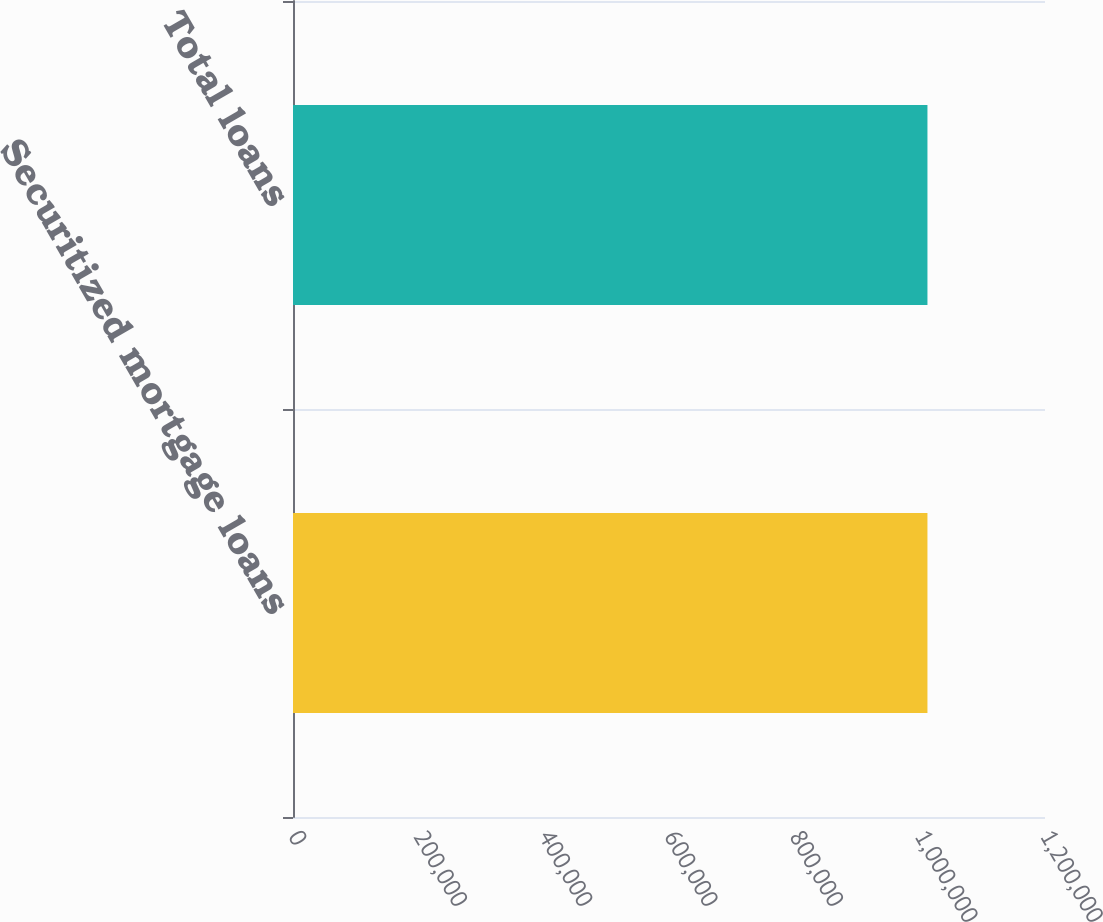Convert chart. <chart><loc_0><loc_0><loc_500><loc_500><bar_chart><fcel>Securitized mortgage loans<fcel>Total loans<nl><fcel>1.01241e+06<fcel>1.01241e+06<nl></chart> 